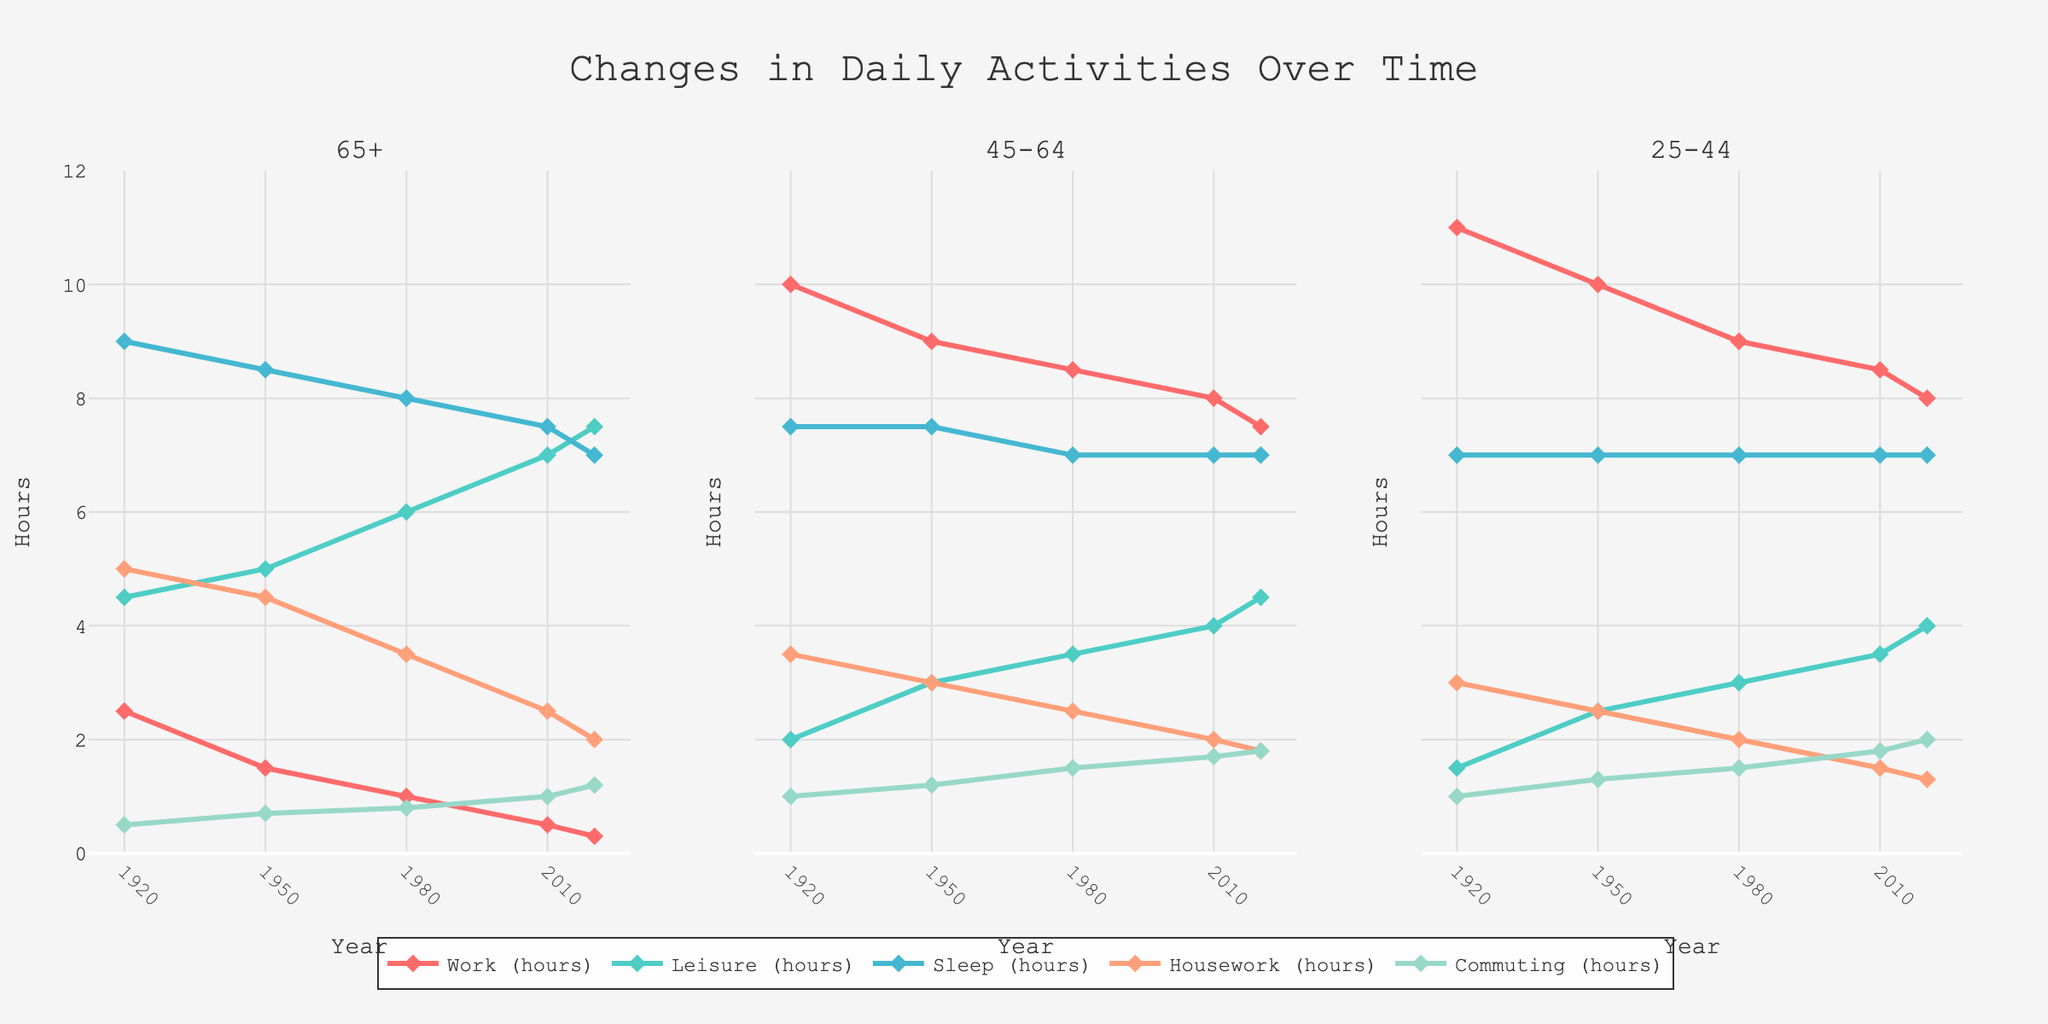What trend do you notice in the average daily work hours for the age group 65+ from 1920 to 2020? The line for "Work (hours)" in the age group 65+ shows a consistent decrease over the years. In 1920, the average daily work hours were around 2.5 hours, and by 2020 it has decreased to 0.3 hours.
Answer: A consistent decrease How do the average daily leisure hours compare between the age groups 25-44 and 65+ in 2020? The line for "Leisure (hours)" in 2020 shows that the age group 65+ spends 7.5 hours on leisure activities, while the age group 25-44 spends 4.0 hours.
Answer: 65+ spends 3.5 hours more Which activity has increased the most in average daily time spent for the age group 45-64 from 1920 to 2020? For the age group 45-64, looking at the trends, "Leisure (hours)" has increased from 2.0 hours in 1920 to 4.5 hours in 2020, an increase of 2.5 hours.
Answer: Leisure What was the daily difference in hours spent on sleep between the age groups 65+ and 25-44 in 1950? In 1950, the line for "Sleep (hours)" shows 8.5 hours for 65+ and 7.0 hours for 25-44. The difference is 8.5 - 7.0 = 1.5 hours.
Answer: 1.5 hours How have the average daily commuting hours changed for the age group 25-44 from 1980 to 2020? The line for "Commuting (hours)" shows an increase from 1.5 hours in 1980 to 2.0 hours in 2020 for the age group 25-44.
Answer: Increased by 0.5 hours Between which years did the average daily housework hours for the age group 65+ decrease the most significantly? The steepest decline in "Housework (hours)" for the age group 65+ occurs between 1980 (3.5 hours) and 2010 (2.5 hours), a decrease of 1.0 hours.
Answer: Between 1980 and 2010 In 2020, which age group spends the least amount of time on work, and how much time do they spend? In 2020, the "Work (hours)" line shows that the age group 65+ spends the least amount of time on work, which is 0.3 hours.
Answer: Age group 65+, 0.3 hours Comparing all age groups, which shows the smallest change in average daily sleep hours from 1920 to 2020? For the age groups 25-44, 45-64, and 65+, the "Sleep (hours)" shows little change over the years. The 25-44 group remains at a consistent 7.0 hours from 1920 to 2020.
Answer: 25-44 What is the absolute difference in average daily leisure hours between the age groups 45-64 and 65+ in 2010? In 2010, the line for "Leisure (hours)" shows 7.0 hours for 65+ and 4.0 hours for 45-64. The absolute difference is 7.0 - 4.0 = 3.0 hours.
Answer: 3.0 hours Looking at housework hours, which age group had a higher amount on average in 1950, and by how much compared to other groups? In 1950, the age group 65+ spent 4.5 hours on housework. Comparing it to 45-64 (3.0 hours) and 25-44 (2.5 hours), the 65+ group spent 1.5 hours more than 45-64 and 2.0 hours more than 25-44.
Answer: 65+, by 1.5 and 2.0 hours respectively 